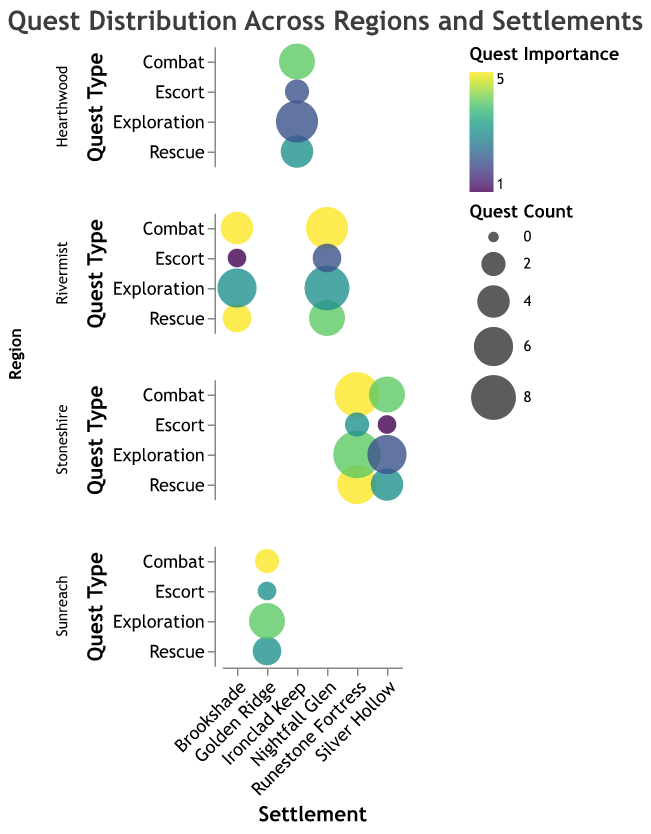What's the title of the chart? The title of the chart is displayed at the top in bold, with a slightly larger font size. It reads "Quest Distribution Across Regions and Settlements".
Answer: Quest Distribution Across Regions and Settlements Which region has the highest quest count for Exploration in at least one of its settlements? To find this, look at each region's subplot and identify which settlement has the highest bubble size for the Exploration quest type. In Stoneshire's Runestone Fortress, Exploration has the highest count with a large bubble size of 9.
Answer: Stoneshire In Nightfall Glen, which quest type has the highest importance? First, locate the Nightfall Glen settlement within the Rivermist region and then identify which bubble has the darkest color, indicating higher importance. The Combat quest type has the highest importance of 5.
Answer: Combat How many Rescue quests are there in Silver Hollow? Look at the Silver Hollow settlement within Stoneshire and find the bubble at the intersection of Settlement and Rescue. The bubble size indicates a count of 4.
Answer: 4 Compare the importance of Combat quests in Golden Ridge to those in Nightfall Glen. Which one has a higher importance? Golden Ridge is in Sunreach, and Nightfall Glen is in Rivermist. Compare the color intensity of the Combat bubbles in these settlements. Golden Ridge's bubble for Combat has an importance of 5, and so does Nightfall Glen's Combat bubble, so they are equal.
Answer: Equal Which settlement has the smallest bubble for Escort quests? To find the smallest bubble, compare the sizes of the bubbles labeled Escort across all settlements. Both Brookshade in Rivermist and Silver Hollow in Stoneshire have the smallest bubble for Escort quests with a count of 1.
Answer: Brookshade and Silver Hollow What's the average count of Combat quests across the Ironclad Keep and Runestone Fortress settlements? First, find the counts for Combat quests in Ironclad Keep (5) and Runestone Fortress (8). Add these counts (5 + 8 = 13) and divide by the number of settlements (2). The average is 13/2 = 6.5.
Answer: 6.5 In Brookshade, which quest type has the lowest count and what is it? Locate the Brookshade settlement in Rivermist, then find the smallest bubble. Escort quests have the lowest count with a size of 1.
Answer: Escort, 1 Out of the Explorational quests in Hearthwood, which settlement has the highest count? In Hearthwood, look at the bubble sizes for Explorational quests in the Ironclad Keep settlement. The size of the bubble indicates a count of 7.
Answer: Ironclad Keep What is the total count of Rescue quests across all regions? Sum the counts for Rescue quests across all entries: 4 (Ironclad Keep) + 3 (Brookshade) + 5 (Nightfall Glen) + 6 (Runestone Fortress) + 4 (Silver Hollow) + 3 (Golden Ridge) = 25.
Answer: 25 